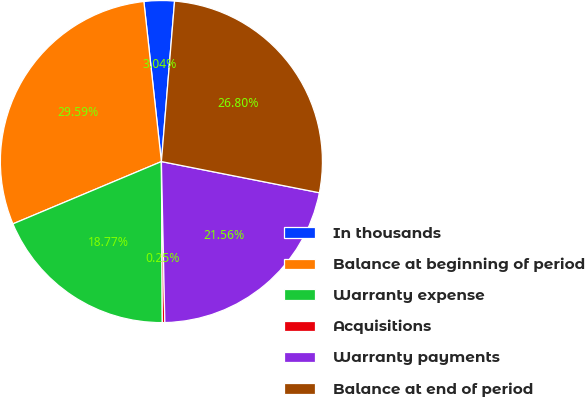Convert chart. <chart><loc_0><loc_0><loc_500><loc_500><pie_chart><fcel>In thousands<fcel>Balance at beginning of period<fcel>Warranty expense<fcel>Acquisitions<fcel>Warranty payments<fcel>Balance at end of period<nl><fcel>3.04%<fcel>29.59%<fcel>18.77%<fcel>0.25%<fcel>21.56%<fcel>26.8%<nl></chart> 